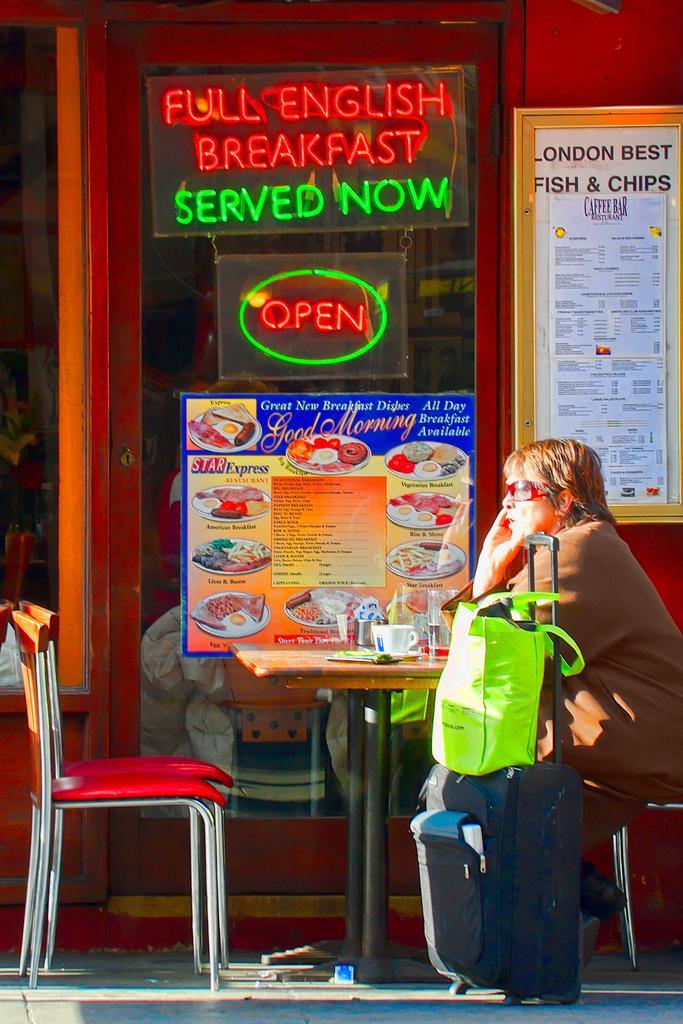How would you summarize this image in a sentence or two? A person is sitting on the chair beside his luggage at the table. In the middle there is a glass door and a poster on it, 